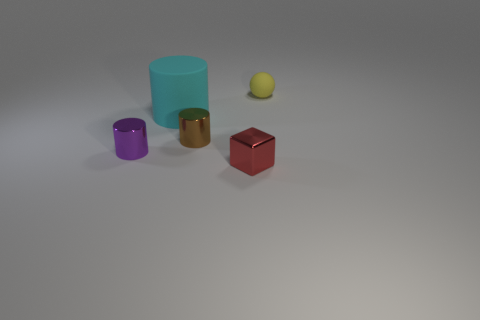Is the color of the small metallic block the same as the large cylinder? no 